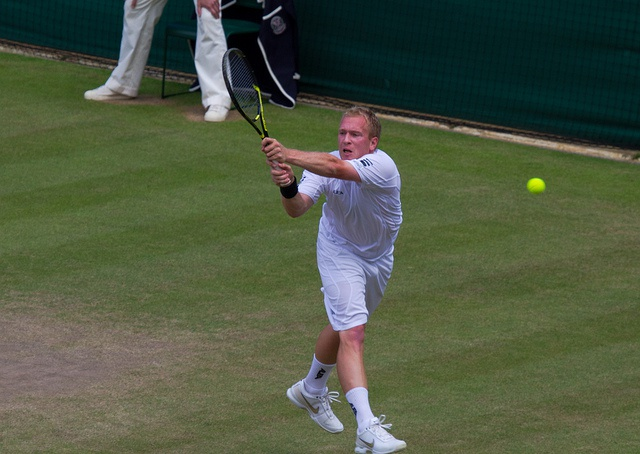Describe the objects in this image and their specific colors. I can see people in black, gray, darkgray, and brown tones, people in black, darkgray, and gray tones, tennis racket in black, darkgreen, and gray tones, chair in black, gray, darkgray, and blue tones, and sports ball in black, yellow, olive, and green tones in this image. 